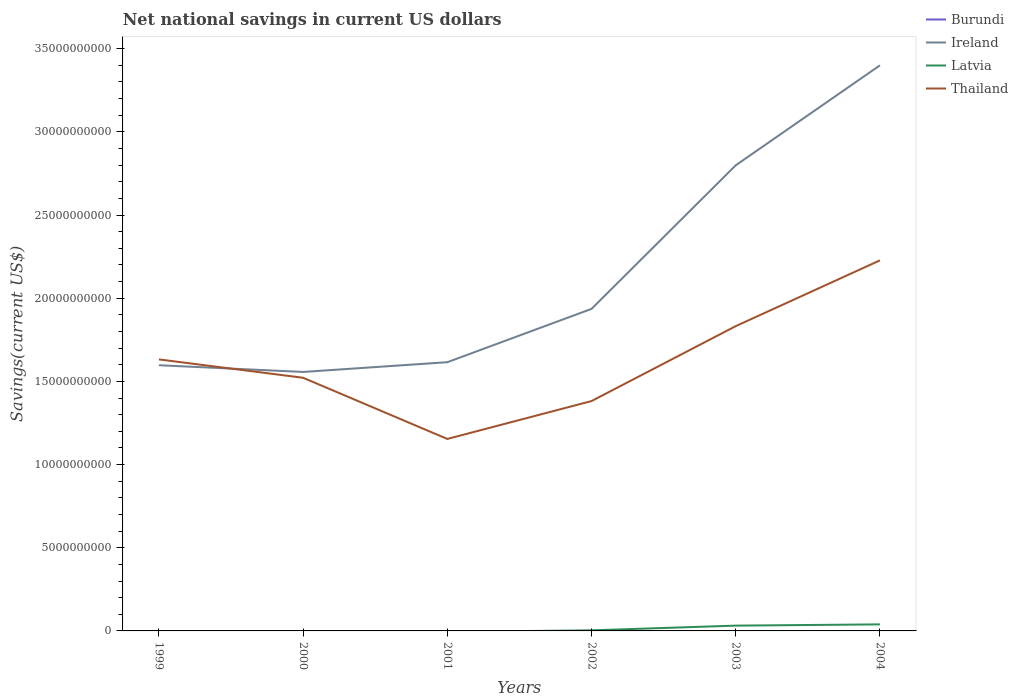What is the total net national savings in Ireland in the graph?
Make the answer very short. -1.18e+1. What is the difference between the highest and the second highest net national savings in Latvia?
Keep it short and to the point. 3.93e+08. Is the net national savings in Burundi strictly greater than the net national savings in Thailand over the years?
Ensure brevity in your answer.  Yes. Are the values on the major ticks of Y-axis written in scientific E-notation?
Offer a terse response. No. Does the graph contain grids?
Give a very brief answer. No. Where does the legend appear in the graph?
Your answer should be very brief. Top right. What is the title of the graph?
Give a very brief answer. Net national savings in current US dollars. What is the label or title of the X-axis?
Provide a succinct answer. Years. What is the label or title of the Y-axis?
Your response must be concise. Savings(current US$). What is the Savings(current US$) of Burundi in 1999?
Offer a terse response. 0. What is the Savings(current US$) of Ireland in 1999?
Provide a short and direct response. 1.60e+1. What is the Savings(current US$) in Latvia in 1999?
Your answer should be compact. 0. What is the Savings(current US$) in Thailand in 1999?
Your answer should be compact. 1.63e+1. What is the Savings(current US$) of Ireland in 2000?
Your answer should be compact. 1.56e+1. What is the Savings(current US$) in Thailand in 2000?
Ensure brevity in your answer.  1.52e+1. What is the Savings(current US$) in Burundi in 2001?
Give a very brief answer. 0. What is the Savings(current US$) of Ireland in 2001?
Keep it short and to the point. 1.62e+1. What is the Savings(current US$) in Latvia in 2001?
Provide a succinct answer. 0. What is the Savings(current US$) of Thailand in 2001?
Give a very brief answer. 1.15e+1. What is the Savings(current US$) in Ireland in 2002?
Your response must be concise. 1.94e+1. What is the Savings(current US$) of Latvia in 2002?
Ensure brevity in your answer.  3.52e+07. What is the Savings(current US$) of Thailand in 2002?
Your answer should be compact. 1.38e+1. What is the Savings(current US$) in Ireland in 2003?
Make the answer very short. 2.80e+1. What is the Savings(current US$) of Latvia in 2003?
Provide a short and direct response. 3.18e+08. What is the Savings(current US$) in Thailand in 2003?
Offer a very short reply. 1.83e+1. What is the Savings(current US$) of Ireland in 2004?
Ensure brevity in your answer.  3.40e+1. What is the Savings(current US$) in Latvia in 2004?
Provide a short and direct response. 3.93e+08. What is the Savings(current US$) of Thailand in 2004?
Offer a terse response. 2.23e+1. Across all years, what is the maximum Savings(current US$) in Ireland?
Make the answer very short. 3.40e+1. Across all years, what is the maximum Savings(current US$) of Latvia?
Your response must be concise. 3.93e+08. Across all years, what is the maximum Savings(current US$) in Thailand?
Give a very brief answer. 2.23e+1. Across all years, what is the minimum Savings(current US$) in Ireland?
Offer a very short reply. 1.56e+1. Across all years, what is the minimum Savings(current US$) of Latvia?
Provide a short and direct response. 0. Across all years, what is the minimum Savings(current US$) of Thailand?
Provide a short and direct response. 1.15e+1. What is the total Savings(current US$) in Ireland in the graph?
Your answer should be compact. 1.29e+11. What is the total Savings(current US$) of Latvia in the graph?
Your answer should be compact. 7.47e+08. What is the total Savings(current US$) in Thailand in the graph?
Give a very brief answer. 9.75e+1. What is the difference between the Savings(current US$) in Ireland in 1999 and that in 2000?
Make the answer very short. 4.04e+08. What is the difference between the Savings(current US$) of Thailand in 1999 and that in 2000?
Your response must be concise. 1.10e+09. What is the difference between the Savings(current US$) of Ireland in 1999 and that in 2001?
Ensure brevity in your answer.  -1.81e+08. What is the difference between the Savings(current US$) in Thailand in 1999 and that in 2001?
Ensure brevity in your answer.  4.78e+09. What is the difference between the Savings(current US$) of Ireland in 1999 and that in 2002?
Your answer should be compact. -3.39e+09. What is the difference between the Savings(current US$) in Thailand in 1999 and that in 2002?
Offer a very short reply. 2.50e+09. What is the difference between the Savings(current US$) in Ireland in 1999 and that in 2003?
Ensure brevity in your answer.  -1.20e+1. What is the difference between the Savings(current US$) in Thailand in 1999 and that in 2003?
Offer a very short reply. -2.00e+09. What is the difference between the Savings(current US$) of Ireland in 1999 and that in 2004?
Give a very brief answer. -1.80e+1. What is the difference between the Savings(current US$) of Thailand in 1999 and that in 2004?
Give a very brief answer. -5.95e+09. What is the difference between the Savings(current US$) of Ireland in 2000 and that in 2001?
Your response must be concise. -5.86e+08. What is the difference between the Savings(current US$) in Thailand in 2000 and that in 2001?
Offer a terse response. 3.68e+09. What is the difference between the Savings(current US$) in Ireland in 2000 and that in 2002?
Offer a terse response. -3.79e+09. What is the difference between the Savings(current US$) of Thailand in 2000 and that in 2002?
Keep it short and to the point. 1.40e+09. What is the difference between the Savings(current US$) in Ireland in 2000 and that in 2003?
Offer a terse response. -1.24e+1. What is the difference between the Savings(current US$) in Thailand in 2000 and that in 2003?
Offer a very short reply. -3.10e+09. What is the difference between the Savings(current US$) in Ireland in 2000 and that in 2004?
Ensure brevity in your answer.  -1.84e+1. What is the difference between the Savings(current US$) in Thailand in 2000 and that in 2004?
Your response must be concise. -7.06e+09. What is the difference between the Savings(current US$) of Ireland in 2001 and that in 2002?
Make the answer very short. -3.21e+09. What is the difference between the Savings(current US$) of Thailand in 2001 and that in 2002?
Your answer should be very brief. -2.28e+09. What is the difference between the Savings(current US$) in Ireland in 2001 and that in 2003?
Keep it short and to the point. -1.18e+1. What is the difference between the Savings(current US$) of Thailand in 2001 and that in 2003?
Your answer should be compact. -6.78e+09. What is the difference between the Savings(current US$) in Ireland in 2001 and that in 2004?
Provide a short and direct response. -1.78e+1. What is the difference between the Savings(current US$) of Thailand in 2001 and that in 2004?
Your answer should be very brief. -1.07e+1. What is the difference between the Savings(current US$) in Ireland in 2002 and that in 2003?
Make the answer very short. -8.63e+09. What is the difference between the Savings(current US$) in Latvia in 2002 and that in 2003?
Your answer should be very brief. -2.83e+08. What is the difference between the Savings(current US$) in Thailand in 2002 and that in 2003?
Your answer should be very brief. -4.50e+09. What is the difference between the Savings(current US$) in Ireland in 2002 and that in 2004?
Provide a succinct answer. -1.46e+1. What is the difference between the Savings(current US$) in Latvia in 2002 and that in 2004?
Keep it short and to the point. -3.58e+08. What is the difference between the Savings(current US$) of Thailand in 2002 and that in 2004?
Give a very brief answer. -8.46e+09. What is the difference between the Savings(current US$) of Ireland in 2003 and that in 2004?
Your response must be concise. -6.01e+09. What is the difference between the Savings(current US$) of Latvia in 2003 and that in 2004?
Keep it short and to the point. -7.53e+07. What is the difference between the Savings(current US$) in Thailand in 2003 and that in 2004?
Your response must be concise. -3.95e+09. What is the difference between the Savings(current US$) in Ireland in 1999 and the Savings(current US$) in Thailand in 2000?
Provide a short and direct response. 7.54e+08. What is the difference between the Savings(current US$) in Ireland in 1999 and the Savings(current US$) in Thailand in 2001?
Your answer should be very brief. 4.43e+09. What is the difference between the Savings(current US$) in Ireland in 1999 and the Savings(current US$) in Latvia in 2002?
Give a very brief answer. 1.59e+1. What is the difference between the Savings(current US$) of Ireland in 1999 and the Savings(current US$) of Thailand in 2002?
Your response must be concise. 2.15e+09. What is the difference between the Savings(current US$) of Ireland in 1999 and the Savings(current US$) of Latvia in 2003?
Provide a succinct answer. 1.57e+1. What is the difference between the Savings(current US$) of Ireland in 1999 and the Savings(current US$) of Thailand in 2003?
Your response must be concise. -2.35e+09. What is the difference between the Savings(current US$) in Ireland in 1999 and the Savings(current US$) in Latvia in 2004?
Ensure brevity in your answer.  1.56e+1. What is the difference between the Savings(current US$) in Ireland in 1999 and the Savings(current US$) in Thailand in 2004?
Keep it short and to the point. -6.30e+09. What is the difference between the Savings(current US$) of Ireland in 2000 and the Savings(current US$) of Thailand in 2001?
Your response must be concise. 4.03e+09. What is the difference between the Savings(current US$) in Ireland in 2000 and the Savings(current US$) in Latvia in 2002?
Offer a terse response. 1.55e+1. What is the difference between the Savings(current US$) of Ireland in 2000 and the Savings(current US$) of Thailand in 2002?
Your answer should be compact. 1.75e+09. What is the difference between the Savings(current US$) of Ireland in 2000 and the Savings(current US$) of Latvia in 2003?
Make the answer very short. 1.53e+1. What is the difference between the Savings(current US$) of Ireland in 2000 and the Savings(current US$) of Thailand in 2003?
Your response must be concise. -2.75e+09. What is the difference between the Savings(current US$) in Ireland in 2000 and the Savings(current US$) in Latvia in 2004?
Ensure brevity in your answer.  1.52e+1. What is the difference between the Savings(current US$) of Ireland in 2000 and the Savings(current US$) of Thailand in 2004?
Provide a short and direct response. -6.71e+09. What is the difference between the Savings(current US$) of Ireland in 2001 and the Savings(current US$) of Latvia in 2002?
Your answer should be very brief. 1.61e+1. What is the difference between the Savings(current US$) in Ireland in 2001 and the Savings(current US$) in Thailand in 2002?
Your answer should be very brief. 2.34e+09. What is the difference between the Savings(current US$) of Ireland in 2001 and the Savings(current US$) of Latvia in 2003?
Make the answer very short. 1.58e+1. What is the difference between the Savings(current US$) of Ireland in 2001 and the Savings(current US$) of Thailand in 2003?
Provide a succinct answer. -2.17e+09. What is the difference between the Savings(current US$) in Ireland in 2001 and the Savings(current US$) in Latvia in 2004?
Your response must be concise. 1.58e+1. What is the difference between the Savings(current US$) of Ireland in 2001 and the Savings(current US$) of Thailand in 2004?
Give a very brief answer. -6.12e+09. What is the difference between the Savings(current US$) of Ireland in 2002 and the Savings(current US$) of Latvia in 2003?
Your answer should be compact. 1.90e+1. What is the difference between the Savings(current US$) of Ireland in 2002 and the Savings(current US$) of Thailand in 2003?
Ensure brevity in your answer.  1.04e+09. What is the difference between the Savings(current US$) of Latvia in 2002 and the Savings(current US$) of Thailand in 2003?
Offer a very short reply. -1.83e+1. What is the difference between the Savings(current US$) of Ireland in 2002 and the Savings(current US$) of Latvia in 2004?
Your answer should be very brief. 1.90e+1. What is the difference between the Savings(current US$) of Ireland in 2002 and the Savings(current US$) of Thailand in 2004?
Provide a succinct answer. -2.92e+09. What is the difference between the Savings(current US$) of Latvia in 2002 and the Savings(current US$) of Thailand in 2004?
Your answer should be compact. -2.22e+1. What is the difference between the Savings(current US$) in Ireland in 2003 and the Savings(current US$) in Latvia in 2004?
Offer a very short reply. 2.76e+1. What is the difference between the Savings(current US$) of Ireland in 2003 and the Savings(current US$) of Thailand in 2004?
Give a very brief answer. 5.72e+09. What is the difference between the Savings(current US$) of Latvia in 2003 and the Savings(current US$) of Thailand in 2004?
Keep it short and to the point. -2.20e+1. What is the average Savings(current US$) of Ireland per year?
Your answer should be compact. 2.15e+1. What is the average Savings(current US$) of Latvia per year?
Give a very brief answer. 1.24e+08. What is the average Savings(current US$) in Thailand per year?
Your answer should be compact. 1.63e+1. In the year 1999, what is the difference between the Savings(current US$) in Ireland and Savings(current US$) in Thailand?
Ensure brevity in your answer.  -3.50e+08. In the year 2000, what is the difference between the Savings(current US$) in Ireland and Savings(current US$) in Thailand?
Your answer should be very brief. 3.50e+08. In the year 2001, what is the difference between the Savings(current US$) in Ireland and Savings(current US$) in Thailand?
Keep it short and to the point. 4.61e+09. In the year 2002, what is the difference between the Savings(current US$) of Ireland and Savings(current US$) of Latvia?
Ensure brevity in your answer.  1.93e+1. In the year 2002, what is the difference between the Savings(current US$) in Ireland and Savings(current US$) in Thailand?
Provide a short and direct response. 5.54e+09. In the year 2002, what is the difference between the Savings(current US$) in Latvia and Savings(current US$) in Thailand?
Offer a very short reply. -1.38e+1. In the year 2003, what is the difference between the Savings(current US$) in Ireland and Savings(current US$) in Latvia?
Offer a very short reply. 2.77e+1. In the year 2003, what is the difference between the Savings(current US$) in Ireland and Savings(current US$) in Thailand?
Give a very brief answer. 9.67e+09. In the year 2003, what is the difference between the Savings(current US$) of Latvia and Savings(current US$) of Thailand?
Ensure brevity in your answer.  -1.80e+1. In the year 2004, what is the difference between the Savings(current US$) in Ireland and Savings(current US$) in Latvia?
Offer a terse response. 3.36e+1. In the year 2004, what is the difference between the Savings(current US$) in Ireland and Savings(current US$) in Thailand?
Your answer should be very brief. 1.17e+1. In the year 2004, what is the difference between the Savings(current US$) of Latvia and Savings(current US$) of Thailand?
Offer a very short reply. -2.19e+1. What is the ratio of the Savings(current US$) in Thailand in 1999 to that in 2000?
Your answer should be very brief. 1.07. What is the ratio of the Savings(current US$) in Ireland in 1999 to that in 2001?
Your response must be concise. 0.99. What is the ratio of the Savings(current US$) of Thailand in 1999 to that in 2001?
Ensure brevity in your answer.  1.41. What is the ratio of the Savings(current US$) of Ireland in 1999 to that in 2002?
Keep it short and to the point. 0.82. What is the ratio of the Savings(current US$) in Thailand in 1999 to that in 2002?
Ensure brevity in your answer.  1.18. What is the ratio of the Savings(current US$) in Ireland in 1999 to that in 2003?
Your answer should be very brief. 0.57. What is the ratio of the Savings(current US$) of Thailand in 1999 to that in 2003?
Your response must be concise. 0.89. What is the ratio of the Savings(current US$) of Ireland in 1999 to that in 2004?
Provide a succinct answer. 0.47. What is the ratio of the Savings(current US$) of Thailand in 1999 to that in 2004?
Offer a very short reply. 0.73. What is the ratio of the Savings(current US$) of Ireland in 2000 to that in 2001?
Provide a succinct answer. 0.96. What is the ratio of the Savings(current US$) of Thailand in 2000 to that in 2001?
Your answer should be compact. 1.32. What is the ratio of the Savings(current US$) of Ireland in 2000 to that in 2002?
Keep it short and to the point. 0.8. What is the ratio of the Savings(current US$) in Thailand in 2000 to that in 2002?
Ensure brevity in your answer.  1.1. What is the ratio of the Savings(current US$) of Ireland in 2000 to that in 2003?
Ensure brevity in your answer.  0.56. What is the ratio of the Savings(current US$) of Thailand in 2000 to that in 2003?
Your response must be concise. 0.83. What is the ratio of the Savings(current US$) in Ireland in 2000 to that in 2004?
Provide a short and direct response. 0.46. What is the ratio of the Savings(current US$) in Thailand in 2000 to that in 2004?
Offer a very short reply. 0.68. What is the ratio of the Savings(current US$) of Ireland in 2001 to that in 2002?
Offer a very short reply. 0.83. What is the ratio of the Savings(current US$) of Thailand in 2001 to that in 2002?
Offer a terse response. 0.84. What is the ratio of the Savings(current US$) of Ireland in 2001 to that in 2003?
Provide a short and direct response. 0.58. What is the ratio of the Savings(current US$) of Thailand in 2001 to that in 2003?
Your answer should be very brief. 0.63. What is the ratio of the Savings(current US$) of Ireland in 2001 to that in 2004?
Ensure brevity in your answer.  0.48. What is the ratio of the Savings(current US$) of Thailand in 2001 to that in 2004?
Your response must be concise. 0.52. What is the ratio of the Savings(current US$) in Ireland in 2002 to that in 2003?
Keep it short and to the point. 0.69. What is the ratio of the Savings(current US$) in Latvia in 2002 to that in 2003?
Offer a terse response. 0.11. What is the ratio of the Savings(current US$) of Thailand in 2002 to that in 2003?
Ensure brevity in your answer.  0.75. What is the ratio of the Savings(current US$) of Ireland in 2002 to that in 2004?
Keep it short and to the point. 0.57. What is the ratio of the Savings(current US$) of Latvia in 2002 to that in 2004?
Offer a very short reply. 0.09. What is the ratio of the Savings(current US$) in Thailand in 2002 to that in 2004?
Offer a terse response. 0.62. What is the ratio of the Savings(current US$) of Ireland in 2003 to that in 2004?
Offer a terse response. 0.82. What is the ratio of the Savings(current US$) of Latvia in 2003 to that in 2004?
Give a very brief answer. 0.81. What is the ratio of the Savings(current US$) of Thailand in 2003 to that in 2004?
Make the answer very short. 0.82. What is the difference between the highest and the second highest Savings(current US$) in Ireland?
Offer a terse response. 6.01e+09. What is the difference between the highest and the second highest Savings(current US$) in Latvia?
Your answer should be very brief. 7.53e+07. What is the difference between the highest and the second highest Savings(current US$) in Thailand?
Your answer should be very brief. 3.95e+09. What is the difference between the highest and the lowest Savings(current US$) of Ireland?
Make the answer very short. 1.84e+1. What is the difference between the highest and the lowest Savings(current US$) of Latvia?
Provide a succinct answer. 3.93e+08. What is the difference between the highest and the lowest Savings(current US$) in Thailand?
Keep it short and to the point. 1.07e+1. 